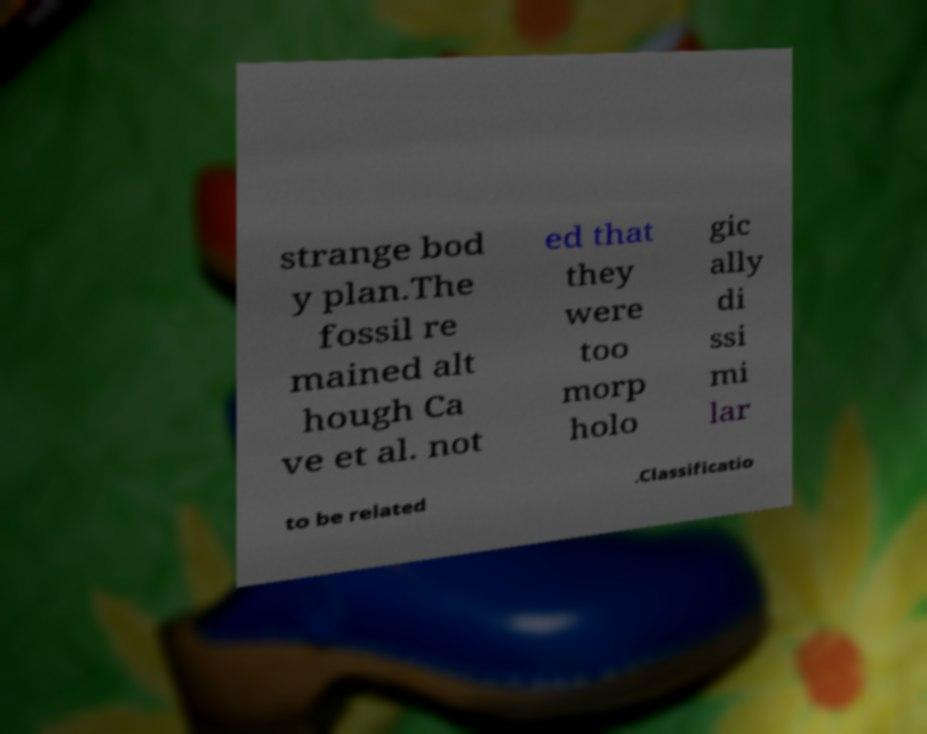Please identify and transcribe the text found in this image. strange bod y plan.The fossil re mained alt hough Ca ve et al. not ed that they were too morp holo gic ally di ssi mi lar to be related .Classificatio 